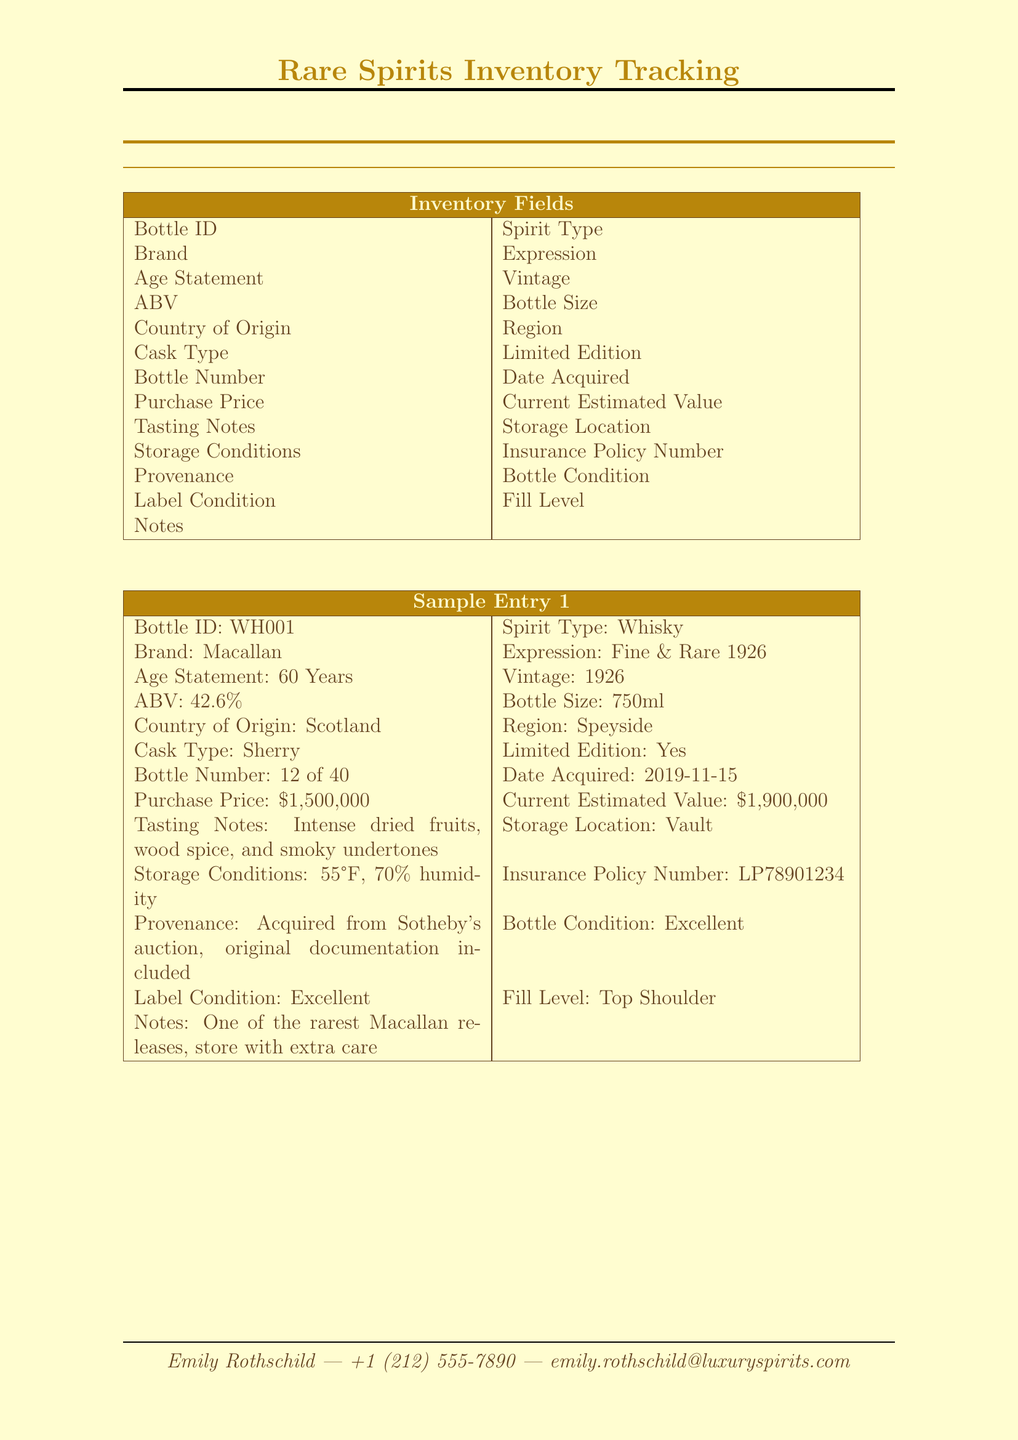What is the name of the collection owner? The name of the collection owner is given in the document as Emily Rothschild.
Answer: Emily Rothschild What is the Bottle ID of the first sample entry? The first sample entry in the document lists the Bottle ID as WH001.
Answer: WH001 What is the current estimated value of the Cognac? The document states the current estimated value of the Cognac as $45,000.
Answer: $45,000 Which storage location is used for the Whisky? The storage location for the Whisky is noted as Vault in the sample entry.
Answer: Vault What is the ABV of the Remy Martin expression? The ABV of the Remy Martin expression is provided in the document as 40%.
Answer: 40% How many bottles are in the limited edition of the Macallan? The document specifies that the Macallan's bottle number is 12 of 40, indicating there are 40 bottles in total for that edition.
Answer: 40 Is the Louis XIII Black Pearl AHD a limited edition? The document clearly indicates that the Louis XIII Black Pearl AHD is a limited edition by stating "Yes."
Answer: Yes What are the storage conditions for the Whisky? The storage conditions for the Whisky are noted as 55°F, 70% humidity.
Answer: 55°F, 70% humidity What type of cask was used for the Cognac? The document lists the cask type for the Cognac as Limousin Oak.
Answer: Limousin Oak 